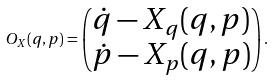<formula> <loc_0><loc_0><loc_500><loc_500>O _ { X } ( q , p ) = \begin{pmatrix} \dot { q } - X _ { q } ( q , p ) \\ \dot { p } - X _ { p } ( q , p ) \end{pmatrix} .</formula> 